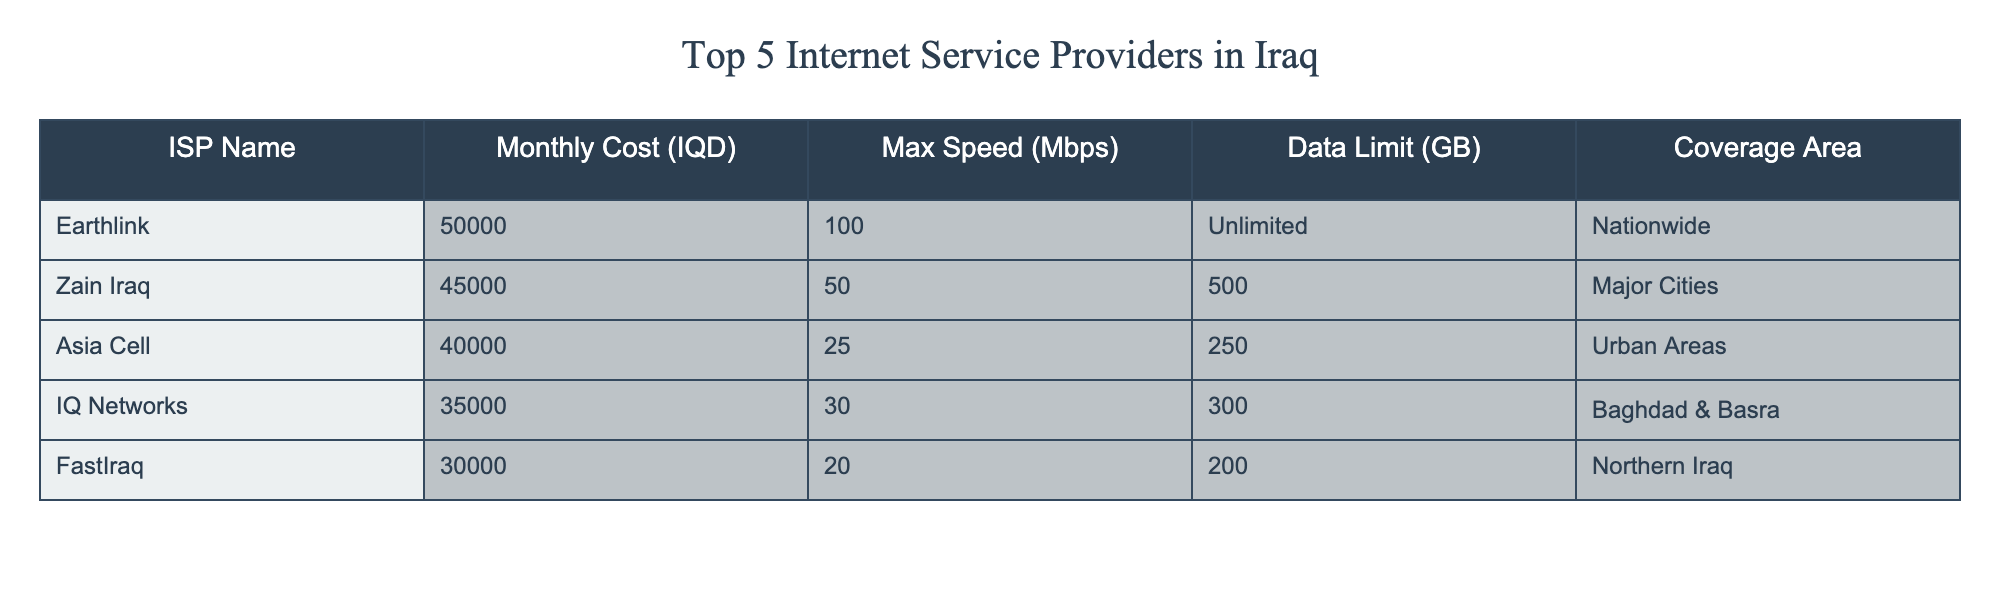What is the monthly cost of FastIraq? The table shows the information for FastIraq under the "Monthly Cost (IQD)" column, which is indicated as 30000.
Answer: 30000 Which ISP has the highest maximum speed? By looking at the "Max Speed (Mbps)" column, Earthlink has the highest speed listed at 100 Mbps.
Answer: Earthlink What is the average monthly cost of the top 5 ISPs? To find the average, sum the monthly costs: 50000 + 45000 + 40000 + 35000 + 30000 = 200000. Then divide by 5 (the number of ISPs): 200000 / 5 = 40000.
Answer: 40000 Is there an ISP that offers unlimited data? The table indicates that Earthlink has "Unlimited" listed under the "Data Limit (GB)" column.
Answer: Yes Which ISPs provide coverage only in a specific area? The "Coverage Area" column shows that Asia Cell and FastIraq provide coverage limited to "Urban Areas" and "Northern Iraq," respectively. Other ISPs such as Earthlink and Zain Iraq have broader coverage.
Answer: Asia Cell and FastIraq 